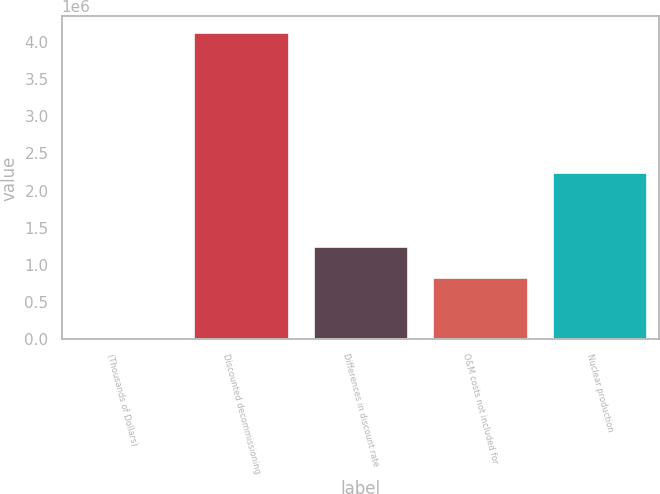Convert chart. <chart><loc_0><loc_0><loc_500><loc_500><bar_chart><fcel>(Thousands of Dollars)<fcel>Discounted decommissioning<fcel>Differences in discount rate<fcel>O&M costs not included for<fcel>Nuclear production<nl><fcel>2016<fcel>4.13713e+06<fcel>1.25767e+06<fcel>844155<fcel>2.24932e+06<nl></chart> 